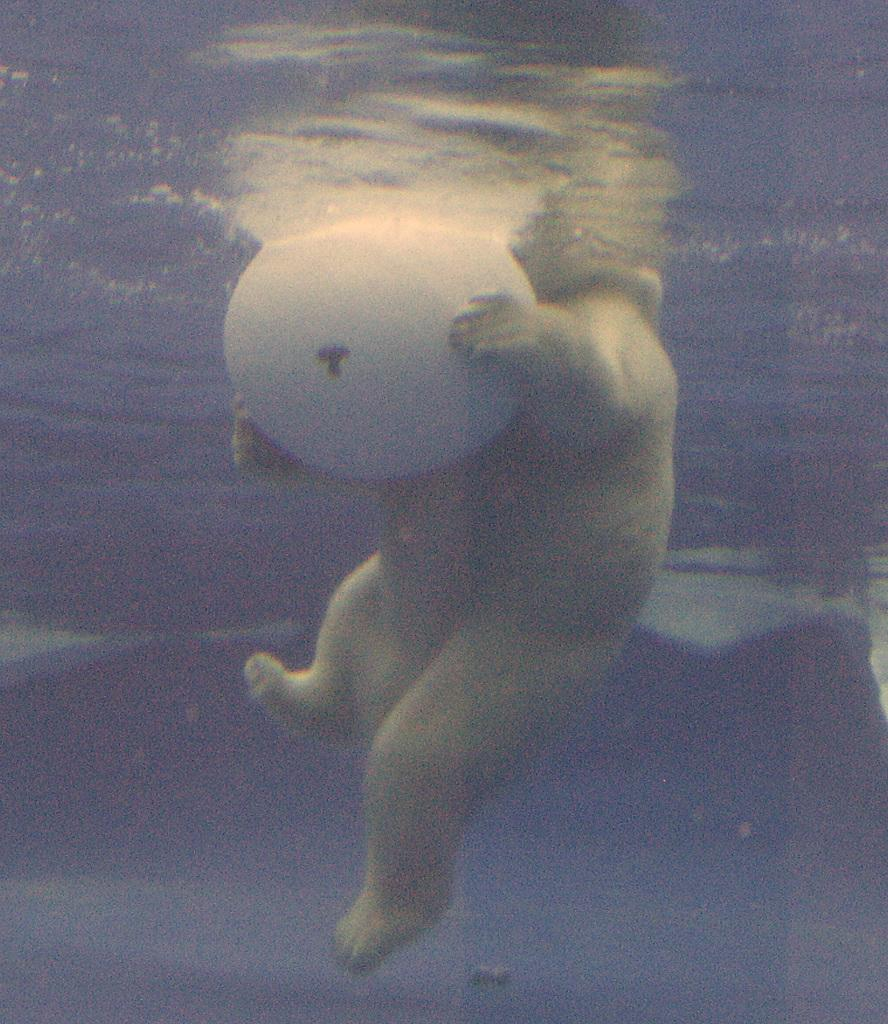What is present in the image that is related to water? There is water visible in the image. What is the white color thing in the image? It is not specified what the white color thing is in the image. What is the green color thing in the image? It is not specified what the green color thing is in the image. Can you describe the snail crawling on the cheese in the image? There is no snail or cheese present in the image. What type of waves can be seen in the image? There is no reference to waves in the image, as it only mentions water and two color-related items. 